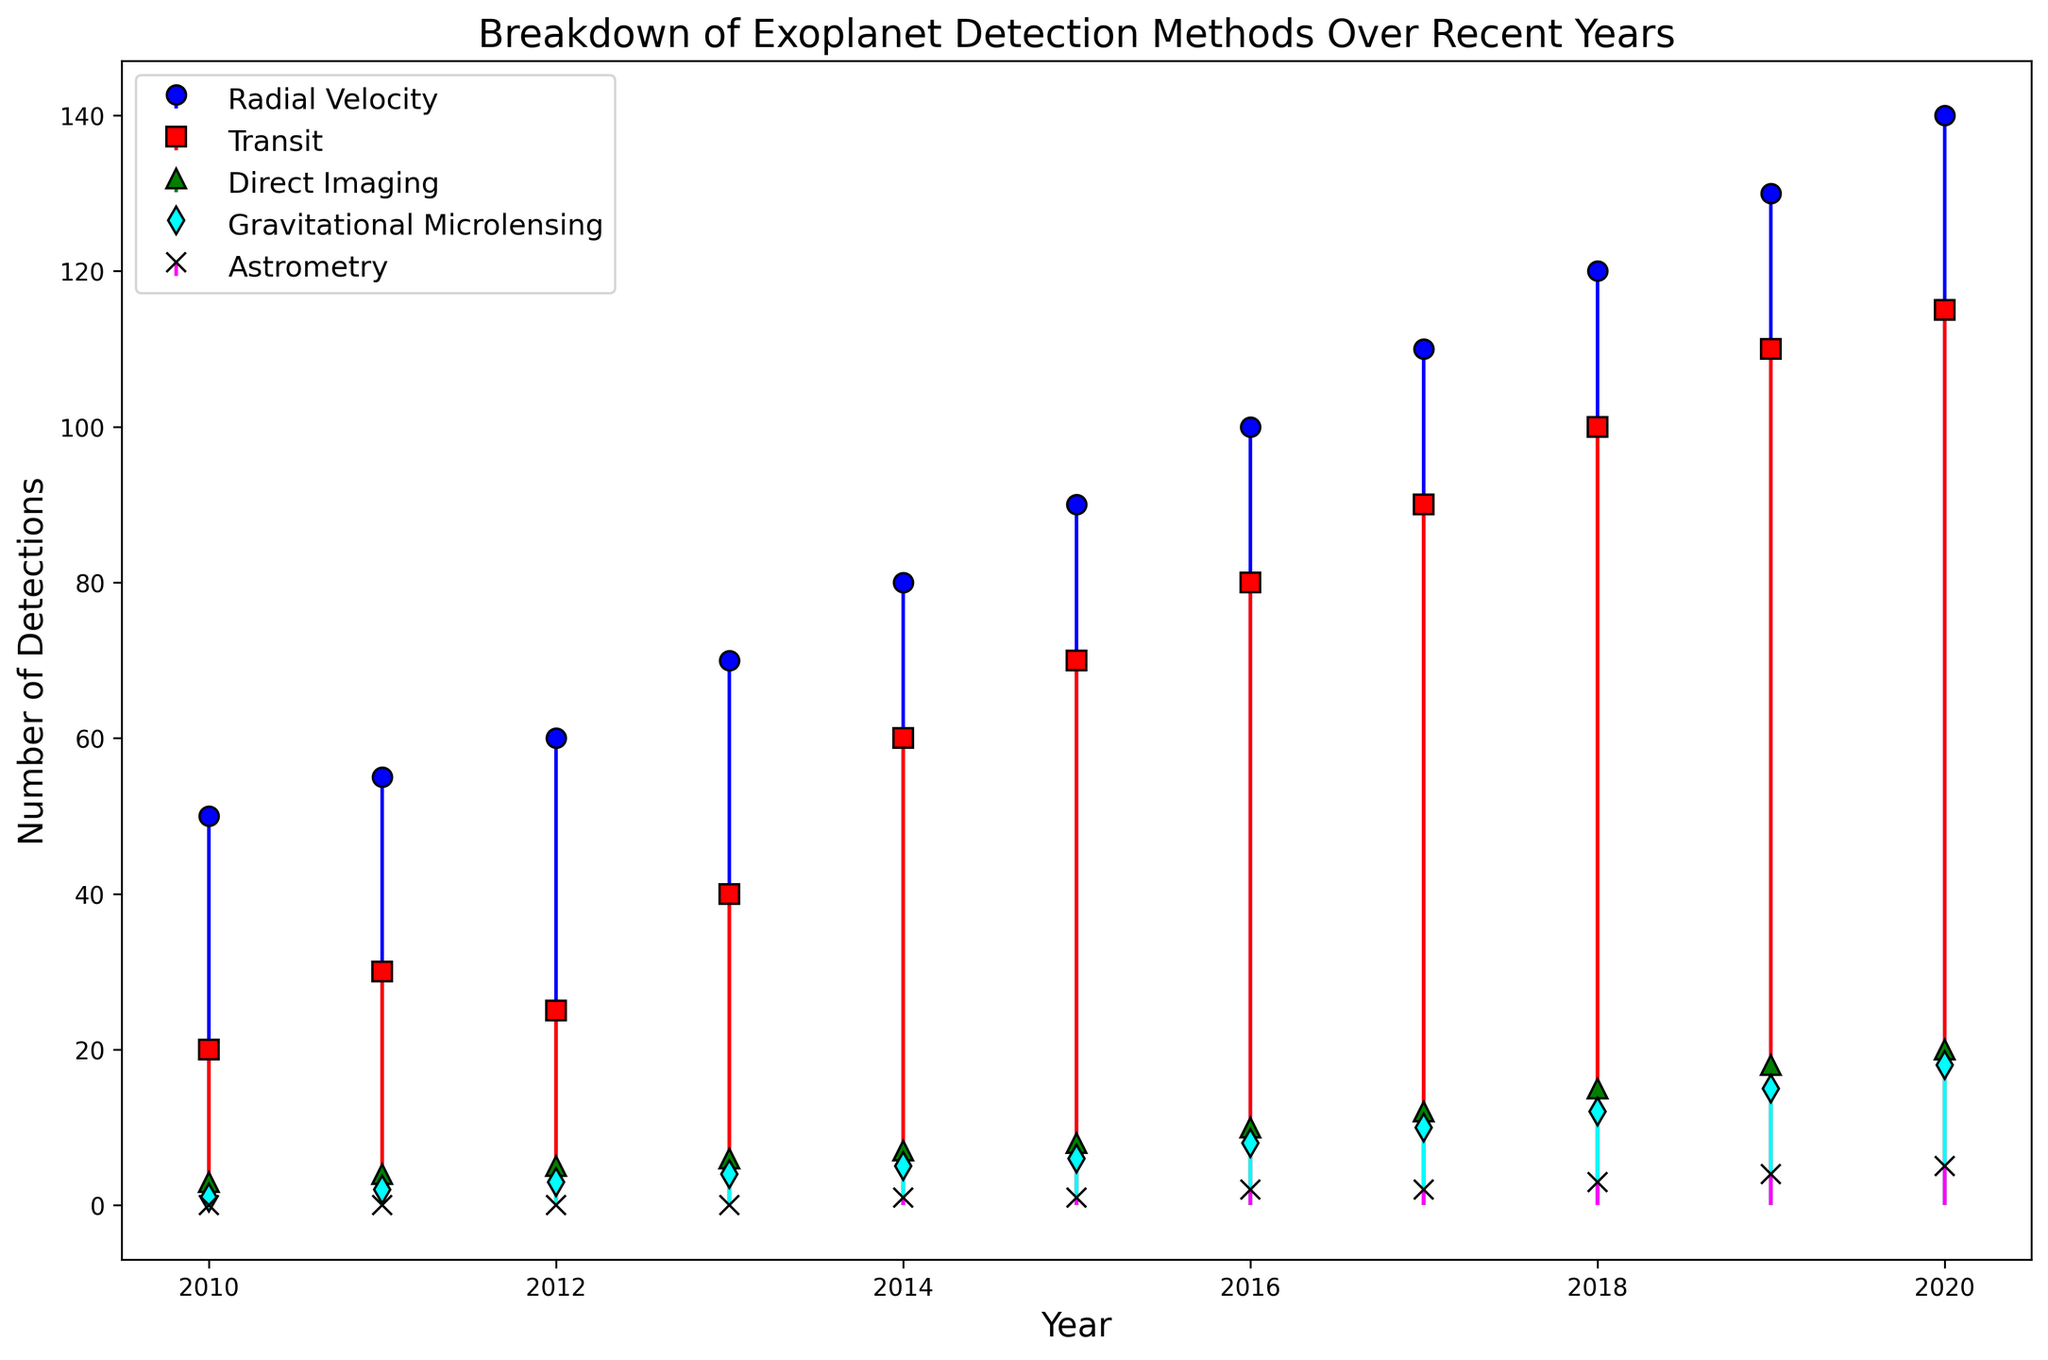What is the total number of exoplanet detections by the Radial Velocity method in 2015? Refer to the stem plot for the year 2015. The height of the blue marker (Radial Velocity) indicates 90 exoplanet detections.
Answer: 90 How many more exoplanets were detected via the Transit method compared to the Direct Imaging method in 2020? Look at the year 2020 on the stem plot. The red marker (Transit) shows 115 detections, and the green marker (Direct Imaging) shows 20 detections. The difference is 115 - 20.
Answer: 95 Which year saw the first detection of exoplanets via the Astrometry method, and how many were detected? Observing the magenta markers (Astrometry) along the x-axis for each year, the first detection appears in 2014 with a single detection.
Answer: 2014, 1 In which year did the number of detections by the Gravitational Microlensing method surpass 10 for the first time? Examine the cyan markers (Gravitational Microlensing). In 2017, the detection count is 10, and in 2018, it jumps to 12. Hence, it first surpasses 10 in 2018.
Answer: 2018 What is the average number of exoplanets detected using the Transit method from 2015 to 2019? Sum the Transit detections for years 2015, 2016, 2017, 2018, and 2019 and divide by 5. The numbers are 70, 80, 90, 100, and 110. Thus, (70 + 80 + 90 + 100 + 110) / 5.
Answer: 90 Compare the trends in exoplanet detections by the Radial Velocity and Transit methods from 2010 to 2020. Which method shows more increase, and by how much? Compare the starting and ending values for Radial Velocity (50 in 2010, 140 in 2020) and Transit (20 in 2010, 115 in 2020). Compute the differences: for Radial Velocity, 140 - 50 = 90; for Transit, 115 - 20 = 95. Transit has a greater increase by 5.
Answer: Transit, 5 Which method consistently shows the smallest number of detections, and how do its detections change over time? Look at the heights of the markers. The magenta markers (Astrometry) show the smallest numbers, starting at 0 and increasing gradually to 5 by 2020.
Answer: Astrometry, gradual increase What are the total detections by the Direct Imaging method from 2010 to 2020? Sum the Direct Imaging detections for each year from the plot: 3, 4, 5, 6, 7, 8, 10, 12, 15, 18, and 20. Thus, 3 + 4 + 5 + 6 + 7 + 8 + 10 + 12 + 15 + 18 + 20 = 108.
Answer: 108 